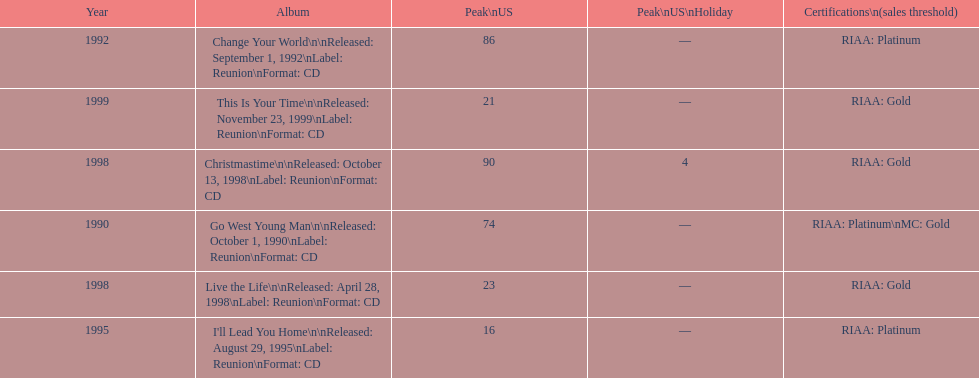What was the first michael w smith album? Go West Young Man. 